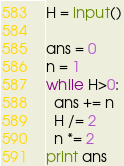<code> <loc_0><loc_0><loc_500><loc_500><_Python_>H = input()

ans = 0
n = 1
while H>0:
  ans += n
  H /= 2
  n *= 2
print ans
</code> 